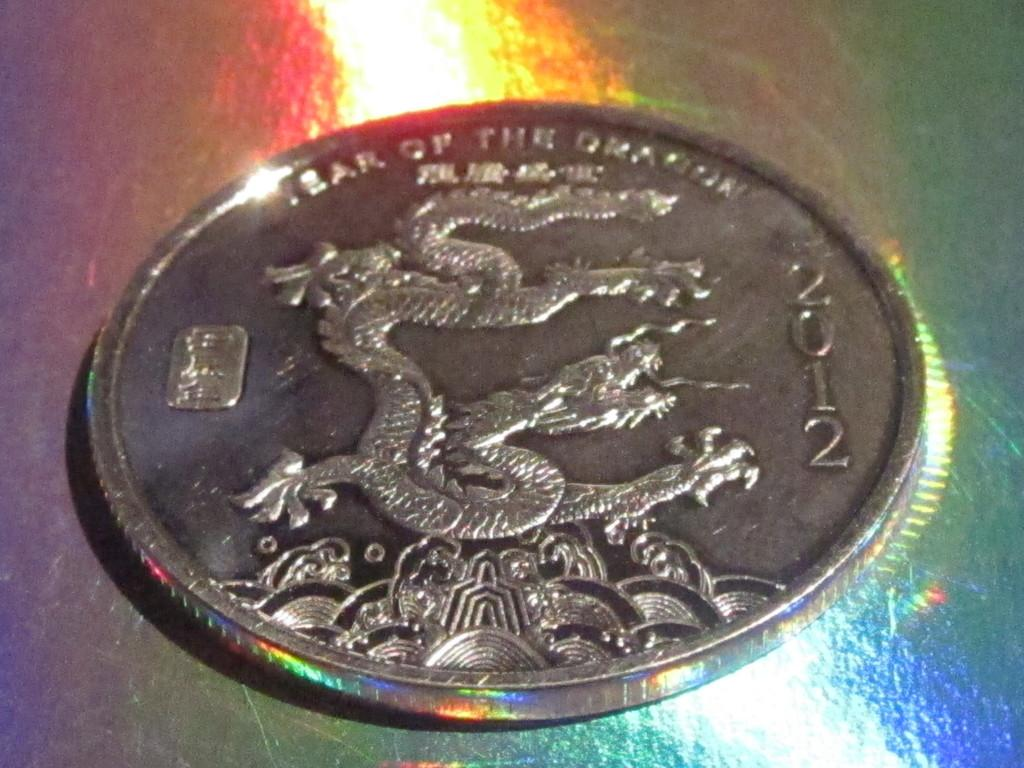<image>
Describe the image concisely. a silver coin that says 'year of the dragon 2012' on it 